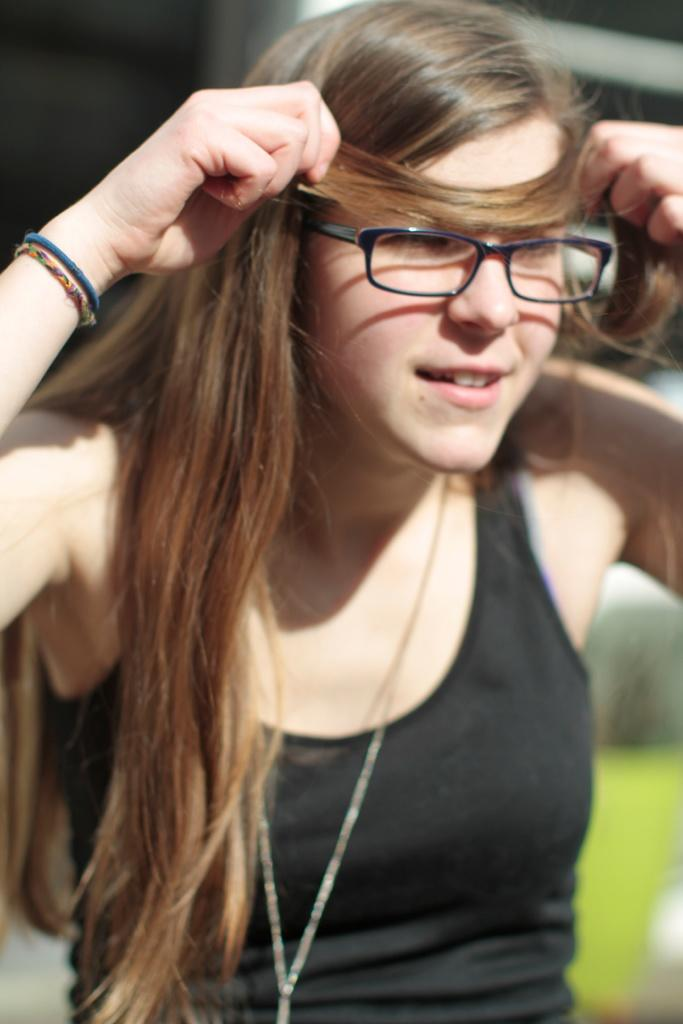Who is the main subject in the image? There is a woman in the image. What is the woman wearing? The woman is wearing a black t-shirt. What expression does the woman have? The woman is smiling. What is the woman doing with her hands? The woman is holding her hair with both hands. What can be seen in the background of the image? There is grass in the background of the image. How is the background of the image depicted? The background is blurred. What type of arm is visible in the image? There is no specific arm mentioned or visible in the image; it features a woman holding her hair with both hands. What type of lizards can be seen in the image? There are no lizards present in the image. 